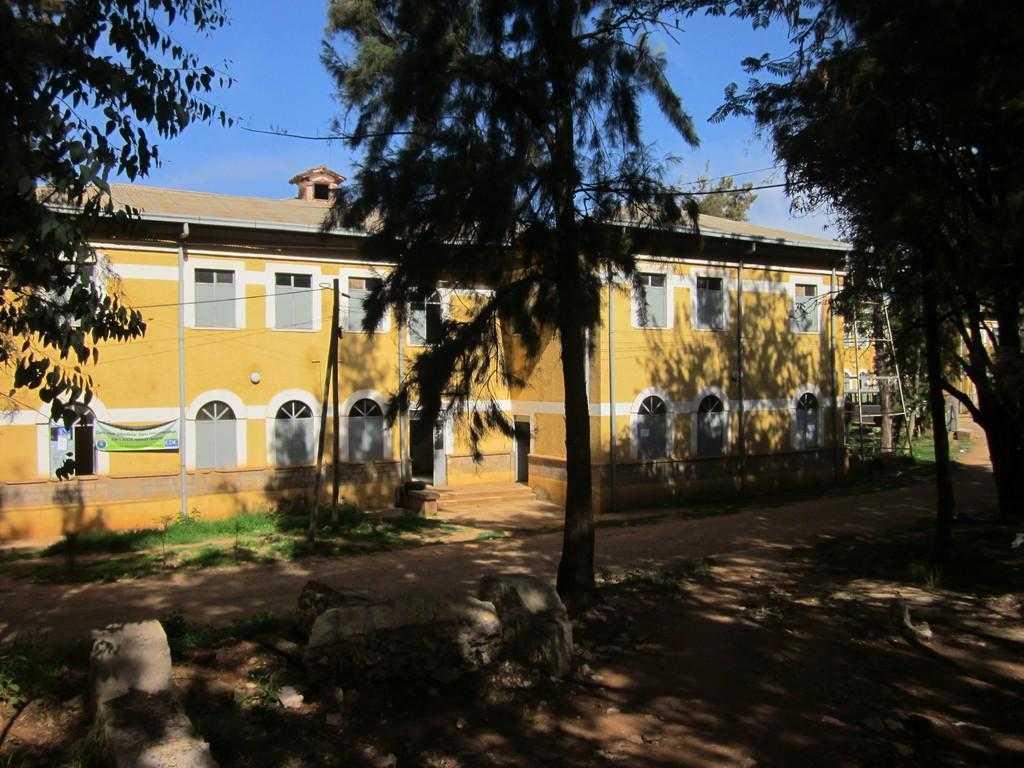What type of structure is visible in the image? There is a building in the image. What feature can be seen on the building? The building has windows. What additional object is present in the image? There is a banner in the image. Are there any architectural features visible in the image? Yes, there are stairs in the image. What type of vegetation is present in the image? There are trees in the image. What is the color of the sky in the image? The sky is blue in color. Can you tell me what type of cork is used in the building's construction? There is no mention of cork being used in the building's construction in the image. 